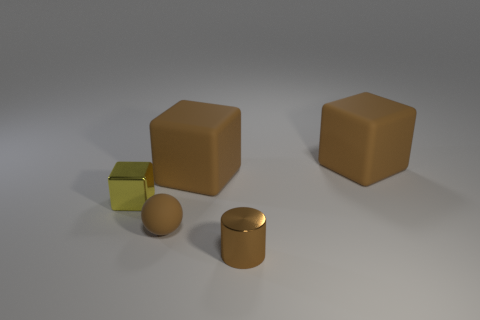Subtract all green cylinders. Subtract all gray cubes. How many cylinders are left? 1 Add 5 blue cylinders. How many objects exist? 10 Subtract all cylinders. How many objects are left? 4 Add 3 brown matte blocks. How many brown matte blocks exist? 5 Subtract 0 red spheres. How many objects are left? 5 Subtract all spheres. Subtract all gray objects. How many objects are left? 4 Add 4 brown cubes. How many brown cubes are left? 6 